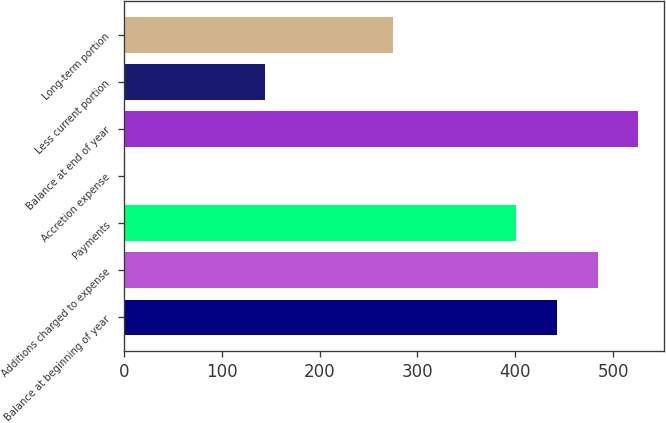<chart> <loc_0><loc_0><loc_500><loc_500><bar_chart><fcel>Balance at beginning of year<fcel>Additions charged to expense<fcel>Payments<fcel>Accretion expense<fcel>Balance at end of year<fcel>Less current portion<fcel>Long-term portion<nl><fcel>442.2<fcel>483.9<fcel>400.5<fcel>1.5<fcel>525.6<fcel>143.9<fcel>274.6<nl></chart> 